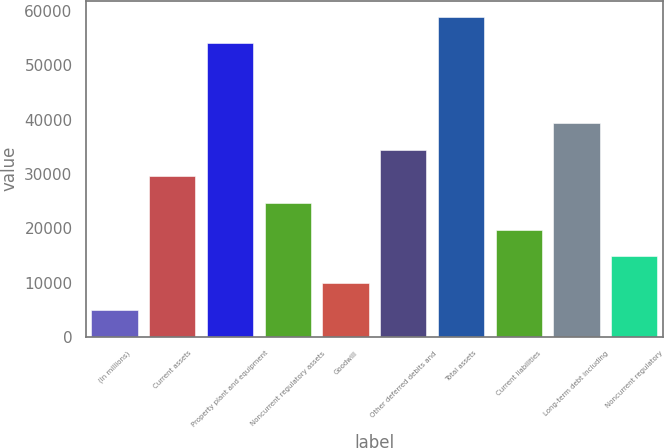<chart> <loc_0><loc_0><loc_500><loc_500><bar_chart><fcel>(In millions)<fcel>Current assets<fcel>Property plant and equipment<fcel>Noncurrent regulatory assets<fcel>Goodwill<fcel>Other deferred debits and<fcel>Total assets<fcel>Current liabilities<fcel>Long-term debt including<fcel>Noncurrent regulatory<nl><fcel>4996.3<fcel>29542.8<fcel>54089.3<fcel>24633.5<fcel>9905.6<fcel>34452.1<fcel>58998.6<fcel>19724.2<fcel>39361.4<fcel>14814.9<nl></chart> 